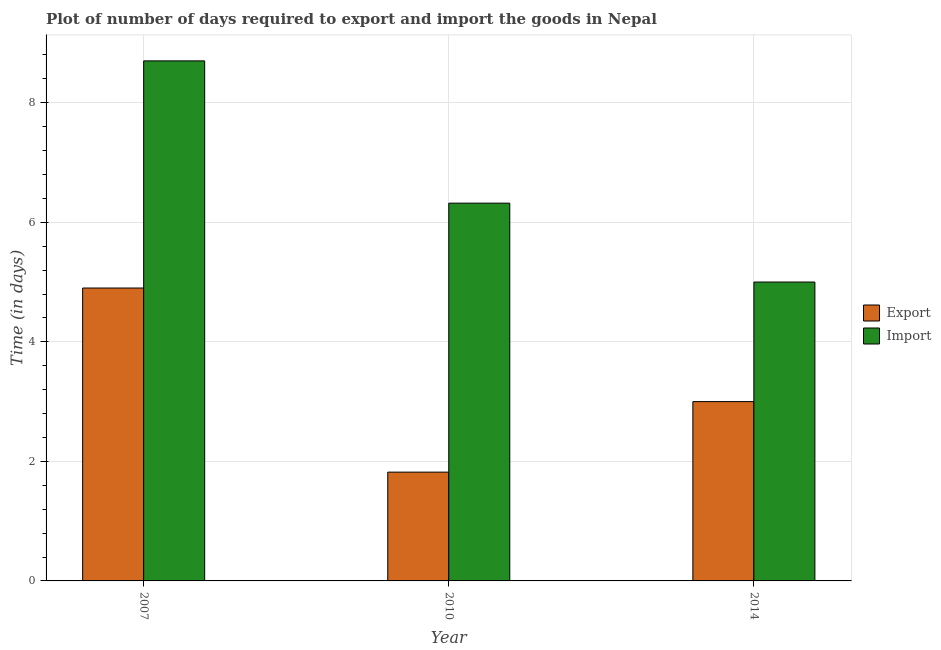How many groups of bars are there?
Make the answer very short. 3. How many bars are there on the 1st tick from the left?
Provide a short and direct response. 2. How many bars are there on the 2nd tick from the right?
Your answer should be very brief. 2. In how many cases, is the number of bars for a given year not equal to the number of legend labels?
Keep it short and to the point. 0. What is the time required to export in 2010?
Ensure brevity in your answer.  1.82. Across all years, what is the maximum time required to export?
Ensure brevity in your answer.  4.9. Across all years, what is the minimum time required to import?
Provide a succinct answer. 5. What is the total time required to import in the graph?
Keep it short and to the point. 20.02. What is the difference between the time required to export in 2007 and that in 2014?
Give a very brief answer. 1.9. What is the difference between the time required to export in 2010 and the time required to import in 2007?
Your answer should be compact. -3.08. What is the average time required to export per year?
Your answer should be very brief. 3.24. What is the ratio of the time required to export in 2010 to that in 2014?
Your answer should be very brief. 0.61. Is the time required to import in 2007 less than that in 2014?
Your response must be concise. No. What is the difference between the highest and the second highest time required to export?
Provide a succinct answer. 1.9. What is the difference between the highest and the lowest time required to export?
Offer a very short reply. 3.08. In how many years, is the time required to export greater than the average time required to export taken over all years?
Give a very brief answer. 1. Is the sum of the time required to export in 2007 and 2014 greater than the maximum time required to import across all years?
Your answer should be compact. Yes. What does the 2nd bar from the left in 2014 represents?
Make the answer very short. Import. What does the 2nd bar from the right in 2007 represents?
Give a very brief answer. Export. How many bars are there?
Offer a terse response. 6. Are all the bars in the graph horizontal?
Your answer should be compact. No. What is the difference between two consecutive major ticks on the Y-axis?
Provide a succinct answer. 2. Where does the legend appear in the graph?
Make the answer very short. Center right. How many legend labels are there?
Provide a succinct answer. 2. How are the legend labels stacked?
Provide a short and direct response. Vertical. What is the title of the graph?
Your response must be concise. Plot of number of days required to export and import the goods in Nepal. Does "RDB nonconcessional" appear as one of the legend labels in the graph?
Ensure brevity in your answer.  No. What is the label or title of the Y-axis?
Provide a short and direct response. Time (in days). What is the Time (in days) of Export in 2007?
Your response must be concise. 4.9. What is the Time (in days) of Import in 2007?
Provide a short and direct response. 8.7. What is the Time (in days) of Export in 2010?
Make the answer very short. 1.82. What is the Time (in days) in Import in 2010?
Give a very brief answer. 6.32. Across all years, what is the maximum Time (in days) in Export?
Provide a succinct answer. 4.9. Across all years, what is the maximum Time (in days) in Import?
Offer a very short reply. 8.7. Across all years, what is the minimum Time (in days) of Export?
Make the answer very short. 1.82. Across all years, what is the minimum Time (in days) in Import?
Your response must be concise. 5. What is the total Time (in days) of Export in the graph?
Your answer should be compact. 9.72. What is the total Time (in days) in Import in the graph?
Make the answer very short. 20.02. What is the difference between the Time (in days) in Export in 2007 and that in 2010?
Offer a terse response. 3.08. What is the difference between the Time (in days) of Import in 2007 and that in 2010?
Keep it short and to the point. 2.38. What is the difference between the Time (in days) in Export in 2007 and that in 2014?
Provide a succinct answer. 1.9. What is the difference between the Time (in days) of Export in 2010 and that in 2014?
Offer a terse response. -1.18. What is the difference between the Time (in days) in Import in 2010 and that in 2014?
Your answer should be very brief. 1.32. What is the difference between the Time (in days) of Export in 2007 and the Time (in days) of Import in 2010?
Keep it short and to the point. -1.42. What is the difference between the Time (in days) of Export in 2010 and the Time (in days) of Import in 2014?
Make the answer very short. -3.18. What is the average Time (in days) in Export per year?
Keep it short and to the point. 3.24. What is the average Time (in days) in Import per year?
Provide a short and direct response. 6.67. What is the ratio of the Time (in days) of Export in 2007 to that in 2010?
Provide a short and direct response. 2.69. What is the ratio of the Time (in days) of Import in 2007 to that in 2010?
Your answer should be compact. 1.38. What is the ratio of the Time (in days) of Export in 2007 to that in 2014?
Your answer should be compact. 1.63. What is the ratio of the Time (in days) in Import in 2007 to that in 2014?
Your answer should be very brief. 1.74. What is the ratio of the Time (in days) in Export in 2010 to that in 2014?
Your response must be concise. 0.61. What is the ratio of the Time (in days) of Import in 2010 to that in 2014?
Provide a short and direct response. 1.26. What is the difference between the highest and the second highest Time (in days) in Import?
Ensure brevity in your answer.  2.38. What is the difference between the highest and the lowest Time (in days) in Export?
Offer a terse response. 3.08. What is the difference between the highest and the lowest Time (in days) of Import?
Offer a very short reply. 3.7. 